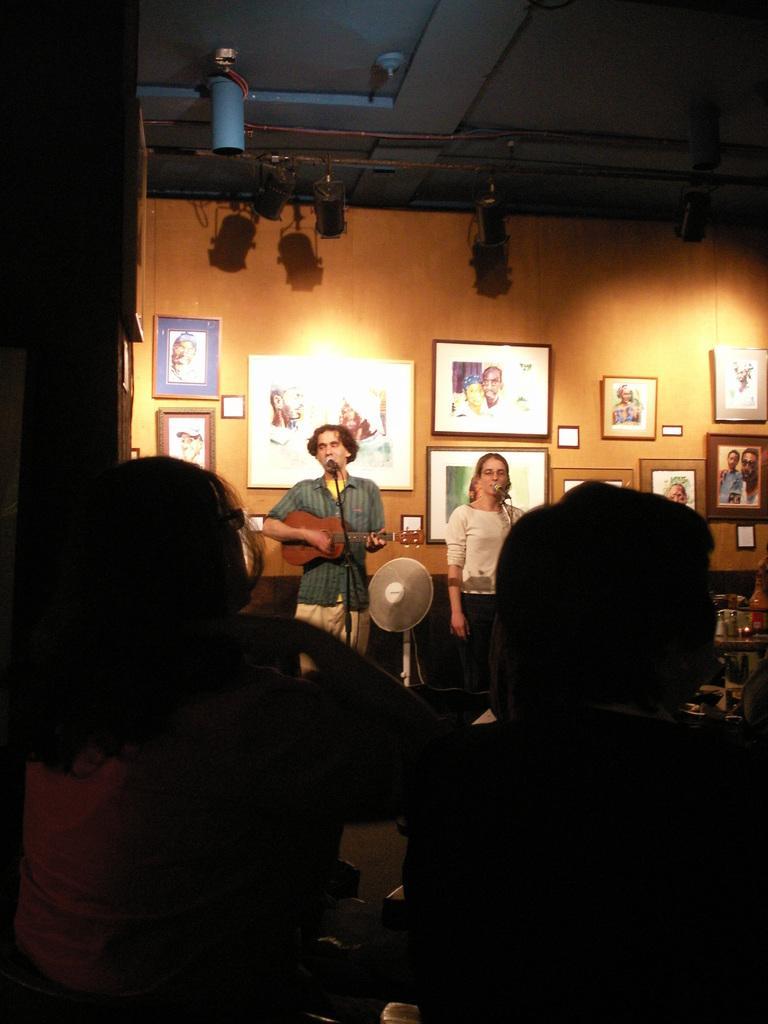Can you describe this image briefly? The person in the left is playing guitar and singing in front of a mic, The person in the right is singing in front of a mic and there are people sitting in front of them. 